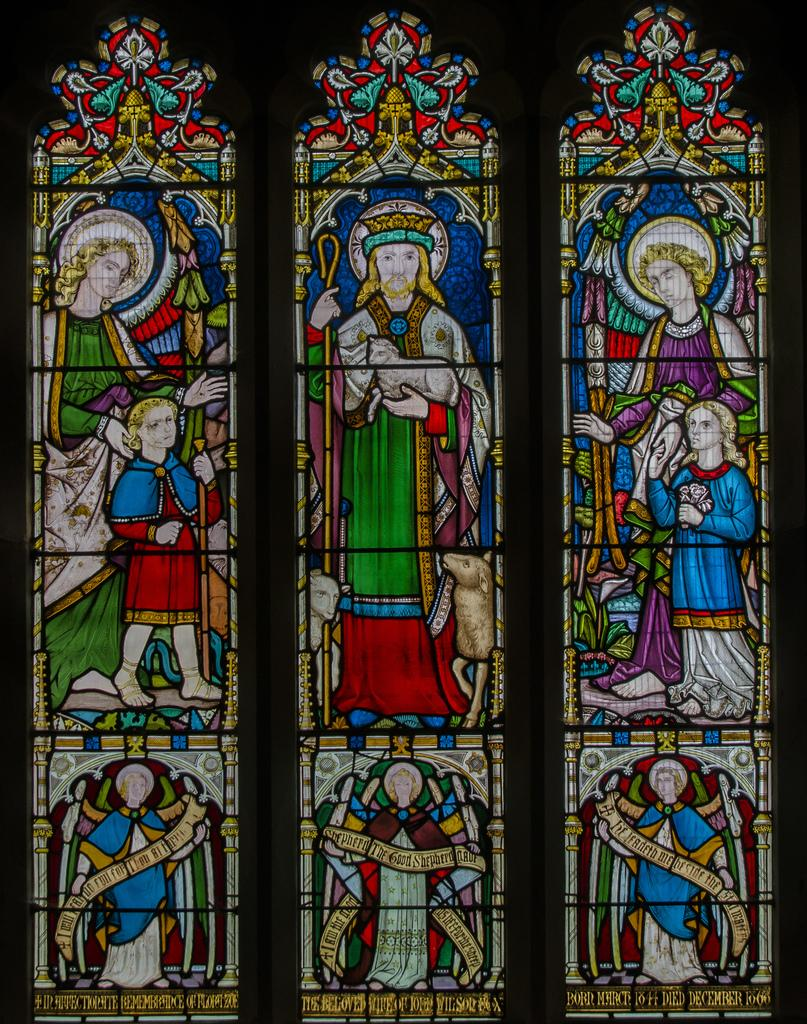What type of glass is depicted in the image? There is a stained glass in the image. Can you describe the appearance of the stained glass? The stained glass features intricate patterns and colors. What might the stained glass be a part of? The stained glass could be a part of a window, door, or other architectural feature. How does the stained glass contribute to the growth of plants in the image? The image does not depict any plants, so the stained glass does not contribute to their growth. 